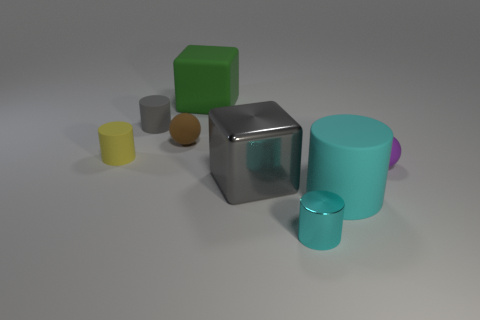There is a matte cylinder in front of the purple ball; does it have the same color as the small shiny cylinder?
Make the answer very short. Yes. Is there a large matte thing that is in front of the small rubber ball that is to the left of the large gray metal thing?
Keep it short and to the point. Yes. There is a big object that is the same shape as the tiny metal thing; what is its color?
Offer a very short reply. Cyan. What size is the green object?
Offer a very short reply. Large. Are there fewer small things that are behind the small purple object than small yellow rubber things?
Provide a short and direct response. No. Are the yellow cylinder and the cube behind the tiny gray matte cylinder made of the same material?
Give a very brief answer. Yes. There is a small thing that is to the right of the matte cylinder that is on the right side of the big green rubber block; is there a gray object that is on the left side of it?
Provide a succinct answer. Yes. The other thing that is made of the same material as the big gray thing is what color?
Your response must be concise. Cyan. How big is the thing that is to the right of the small brown sphere and left of the big gray metallic object?
Your answer should be compact. Large. Is the number of big green cubes to the left of the tiny brown matte ball less than the number of objects in front of the yellow rubber thing?
Provide a succinct answer. Yes. 